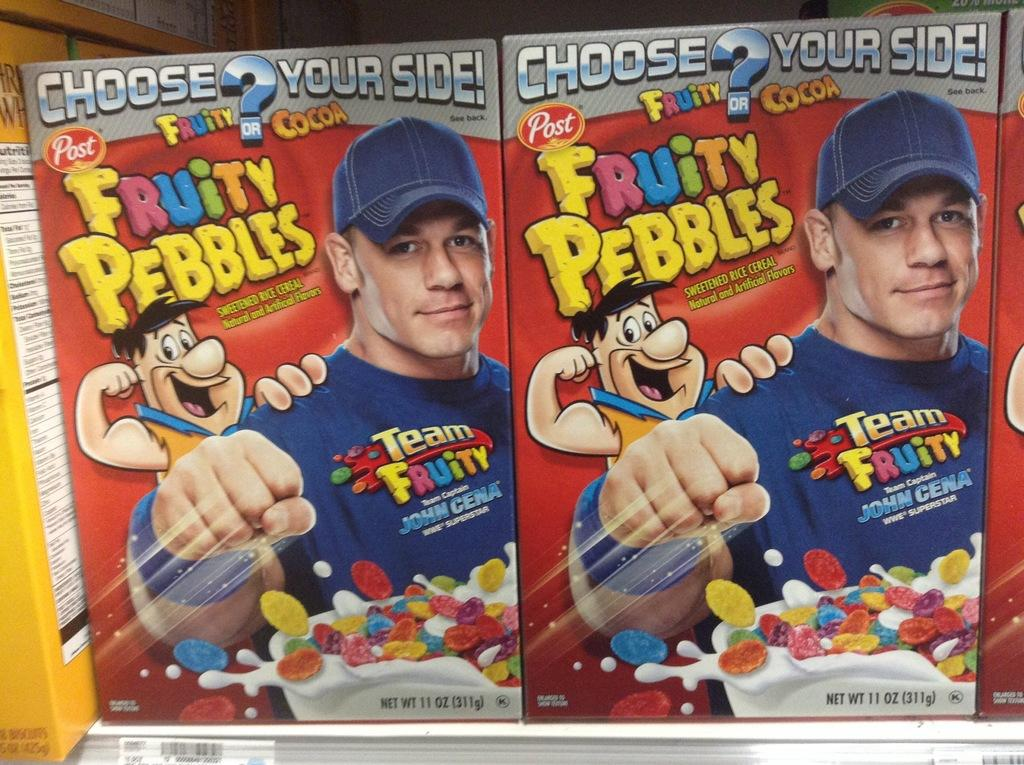How many graphical images are present in the image? There are two graphical images in the image. What is the man doing with his wrist? The man is showing his wrist. What color is the man's t-shirt? The man is wearing a blue t-shirt. What type of headwear is the man wearing? The man is wearing a cap. Can you describe the cartoon man beside the man? There is a cartoon man beside the man in the image. What disease is the man suffering from in the image? There is no indication of any disease in the image; the man is simply showing his wrist. What is the man doing with his elbow in the image? The man is not doing anything with his elbow in the image; he is showing his wrist. 